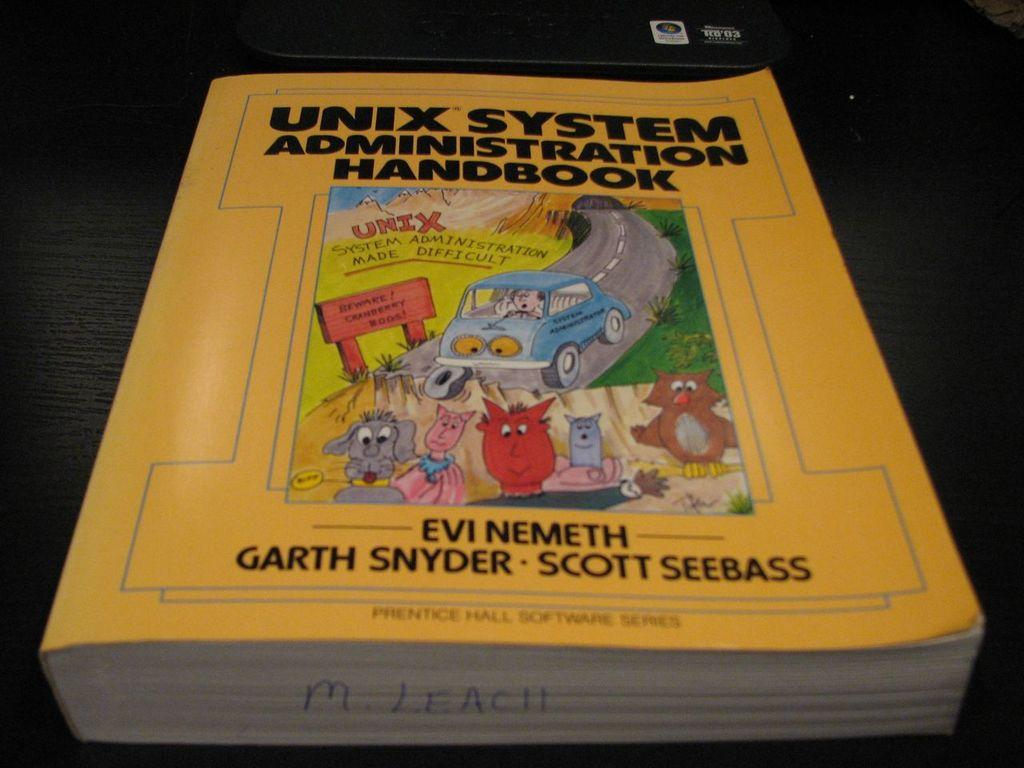What object can be seen in the image? There is a book in the image. Where is the book located? The book is placed on a surface. What can be found on the book? There is text written on the book. How many babies are playing with the toy pen in the image? There is no toy pen or babies present in the image; it only features a book placed on a surface. 